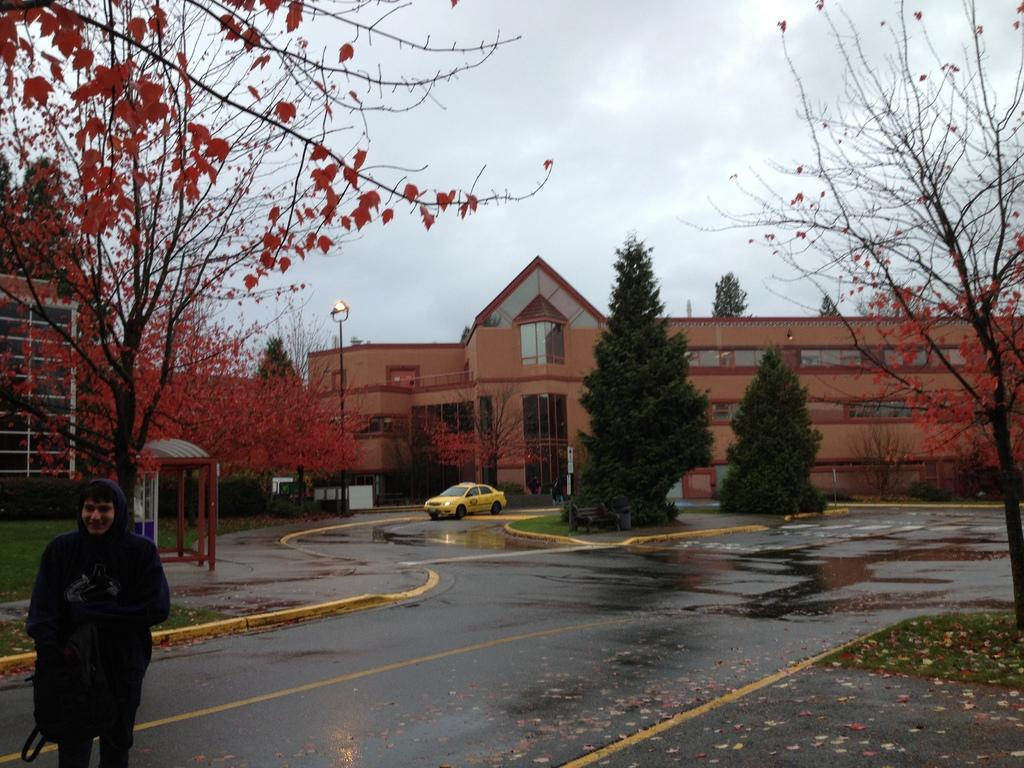What is the main subject of the image? The main subject of the image is a car. Where is the car located in the image? The car is on the road in the image. Can you describe anything on the left side of the image? There is a man standing on the left side of the image. What can be seen in the background of the image? There are trees, a pole, buildings, and the sky visible in the background of the image. What type of letters can be seen on the car in the image? There are no letters visible on the car in the image. How many flowers are present on the pole in the background of the image? There are no flowers present on the pole in the background of the image. 